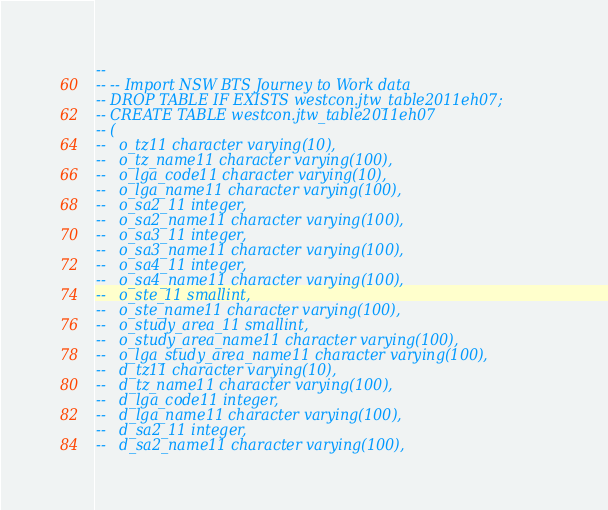Convert code to text. <code><loc_0><loc_0><loc_500><loc_500><_SQL_>-- 
-- -- Import NSW BTS Journey to Work data
-- DROP TABLE IF EXISTS westcon.jtw_table2011eh07;
-- CREATE TABLE westcon.jtw_table2011eh07
-- (
--   o_tz11 character varying(10),
--   o_tz_name11 character varying(100),
--   o_lga_code11 character varying(10),
--   o_lga_name11 character varying(100),
--   o_sa2_11 integer,
--   o_sa2_name11 character varying(100),
--   o_sa3_11 integer,
--   o_sa3_name11 character varying(100),
--   o_sa4_11 integer,
--   o_sa4_name11 character varying(100),
--   o_ste_11 smallint,
--   o_ste_name11 character varying(100),
--   o_study_area_11 smallint,
--   o_study_area_name11 character varying(100),
--   o_lga_study_area_name11 character varying(100),
--   d_tz11 character varying(10),
--   d_tz_name11 character varying(100),
--   d_lga_code11 integer,
--   d_lga_name11 character varying(100),
--   d_sa2_11 integer,
--   d_sa2_name11 character varying(100),</code> 